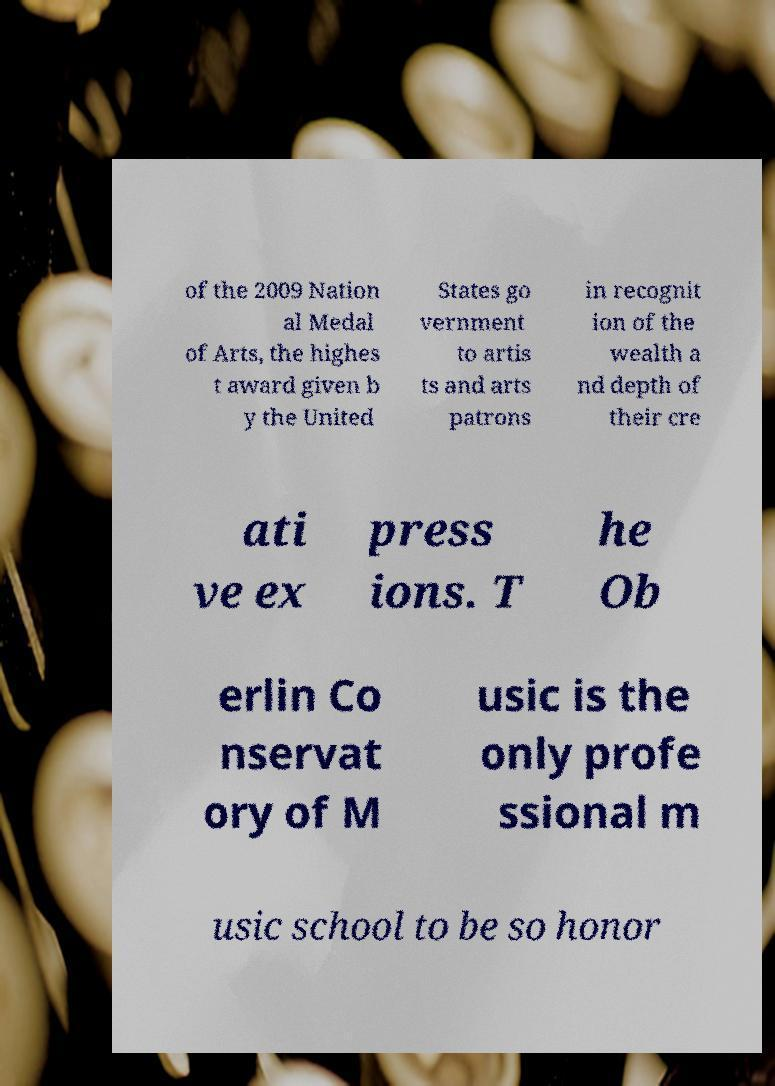Can you read and provide the text displayed in the image?This photo seems to have some interesting text. Can you extract and type it out for me? of the 2009 Nation al Medal of Arts, the highes t award given b y the United States go vernment to artis ts and arts patrons in recognit ion of the wealth a nd depth of their cre ati ve ex press ions. T he Ob erlin Co nservat ory of M usic is the only profe ssional m usic school to be so honor 